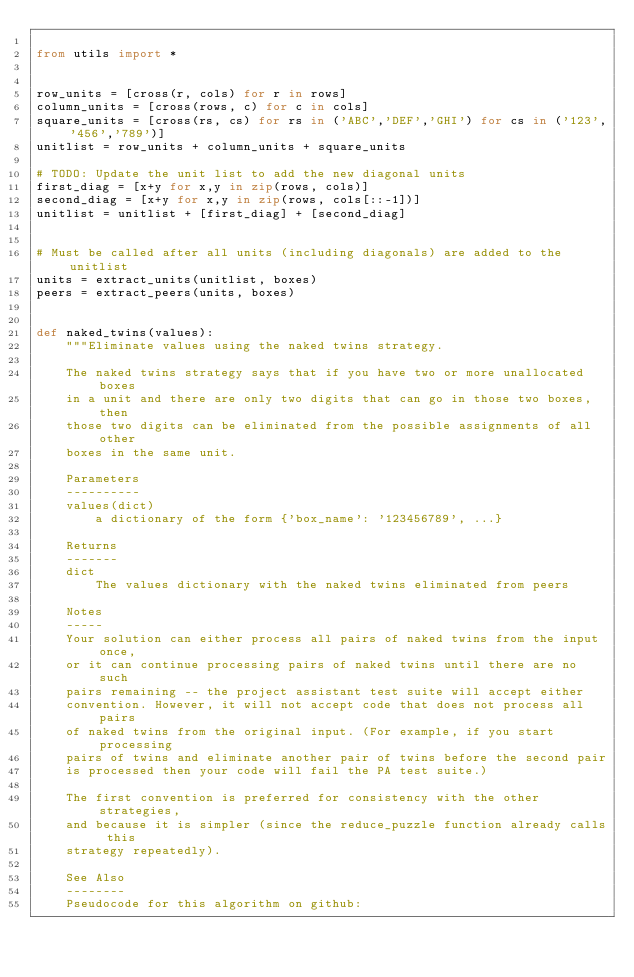Convert code to text. <code><loc_0><loc_0><loc_500><loc_500><_Python_>
from utils import *


row_units = [cross(r, cols) for r in rows]
column_units = [cross(rows, c) for c in cols]
square_units = [cross(rs, cs) for rs in ('ABC','DEF','GHI') for cs in ('123','456','789')]
unitlist = row_units + column_units + square_units

# TODO: Update the unit list to add the new diagonal units
first_diag = [x+y for x,y in zip(rows, cols)]
second_diag = [x+y for x,y in zip(rows, cols[::-1])]
unitlist = unitlist + [first_diag] + [second_diag]


# Must be called after all units (including diagonals) are added to the unitlist
units = extract_units(unitlist, boxes)
peers = extract_peers(units, boxes)


def naked_twins(values):
    """Eliminate values using the naked twins strategy.

    The naked twins strategy says that if you have two or more unallocated boxes
    in a unit and there are only two digits that can go in those two boxes, then
    those two digits can be eliminated from the possible assignments of all other
    boxes in the same unit.

    Parameters
    ----------
    values(dict)
        a dictionary of the form {'box_name': '123456789', ...}

    Returns
    -------
    dict
        The values dictionary with the naked twins eliminated from peers

    Notes
    -----
    Your solution can either process all pairs of naked twins from the input once,
    or it can continue processing pairs of naked twins until there are no such
    pairs remaining -- the project assistant test suite will accept either
    convention. However, it will not accept code that does not process all pairs
    of naked twins from the original input. (For example, if you start processing
    pairs of twins and eliminate another pair of twins before the second pair
    is processed then your code will fail the PA test suite.)

    The first convention is preferred for consistency with the other strategies,
    and because it is simpler (since the reduce_puzzle function already calls this
    strategy repeatedly).

    See Also
    --------
    Pseudocode for this algorithm on github:</code> 